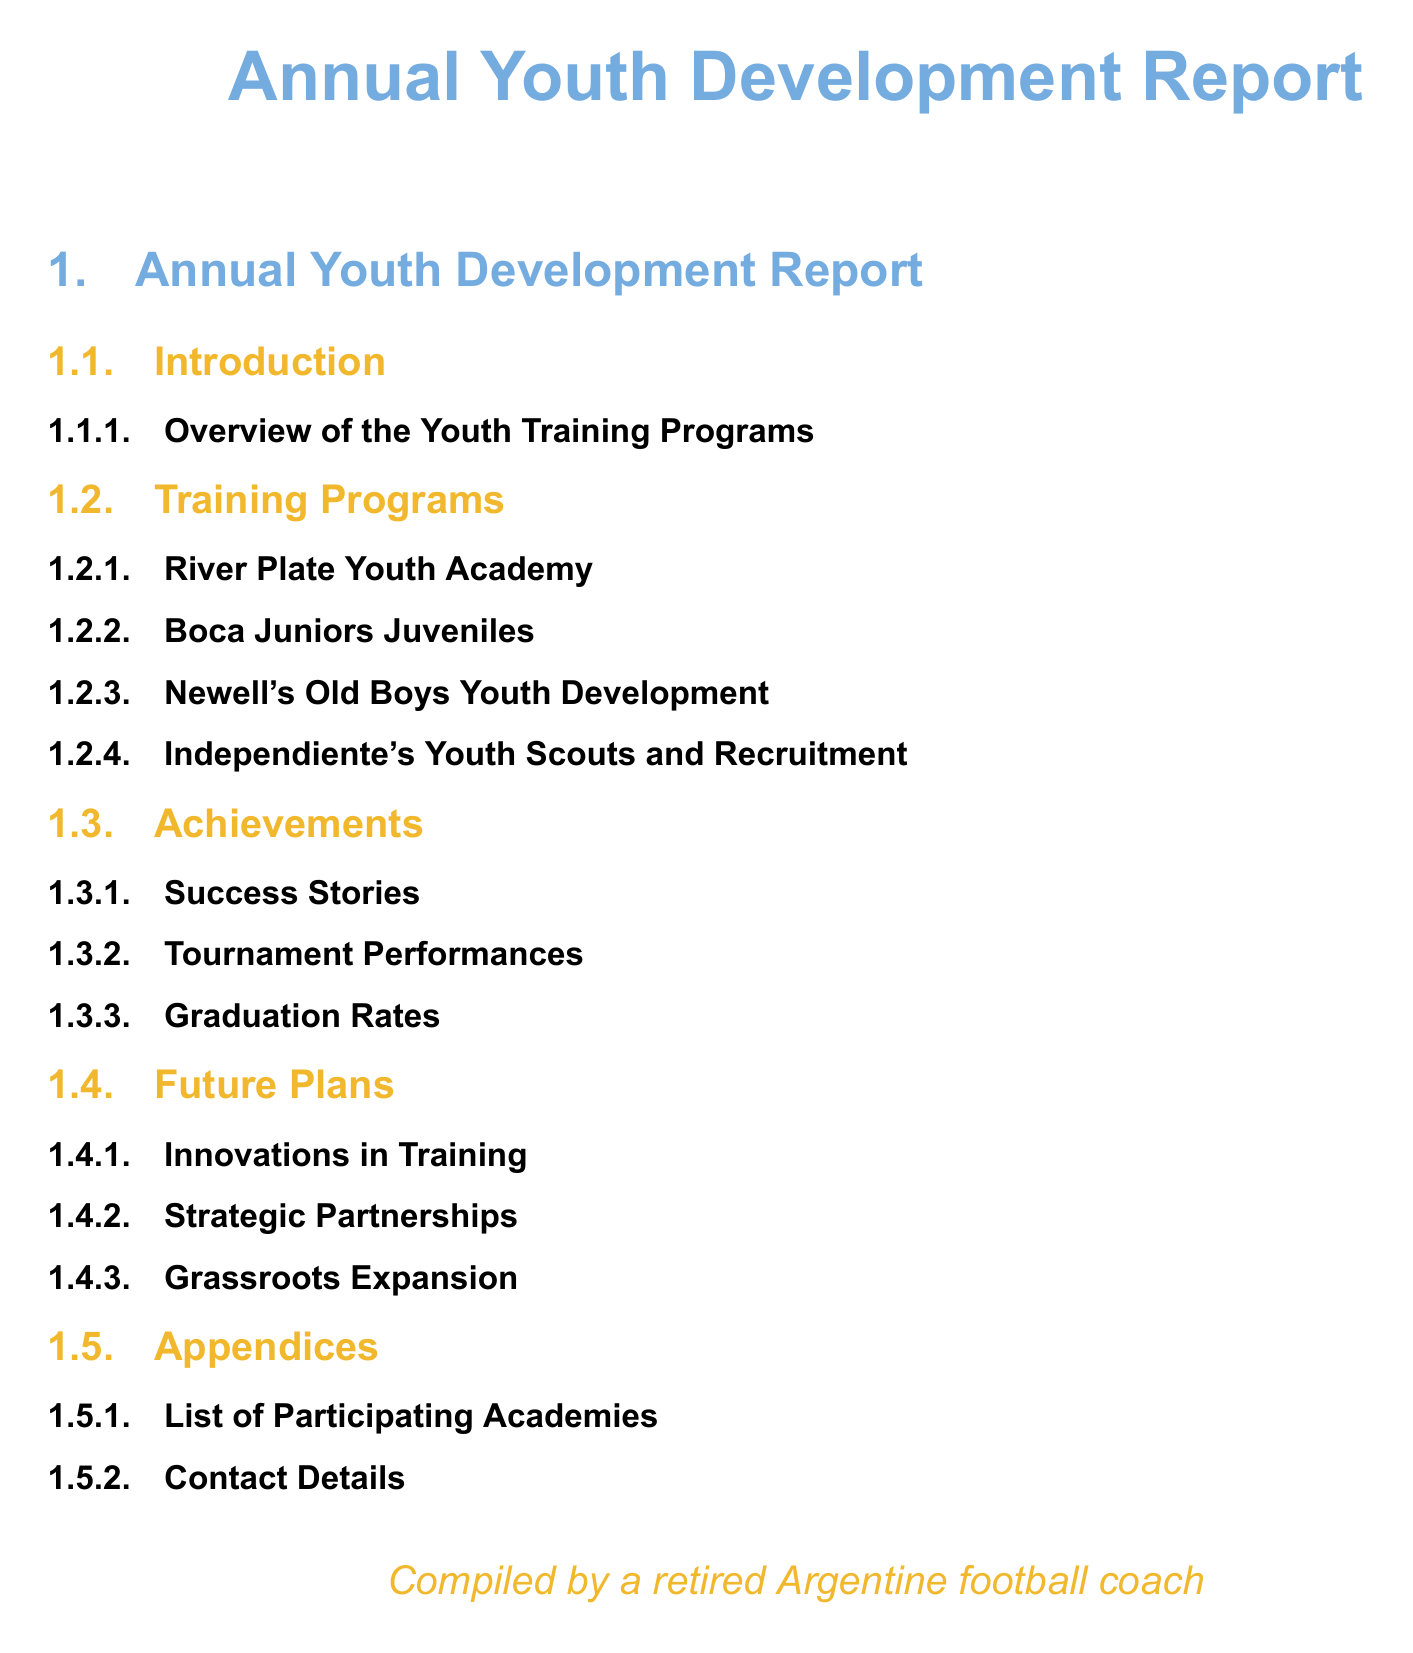what is the title of the report? The title of the report is prominently displayed at the top of the document.
Answer: Annual Youth Development Report how many youth training programs are listed? The number of youth training programs can be determined by counting the subsubsections under Training Programs.
Answer: 4 name one of the youth academies mentioned. This can be found in the Training Programs section, which lists participating academies.
Answer: River Plate Youth Academy what color is used for the section titles? The color of the section titles is specified within the document formatting settings.
Answer: Argentine blue what is one focus area for future plans? This can be identified in the Future Plans section where various strategies are outlined.
Answer: Innovations in Training who compiled the report? The document attributes the compilation to a specific individual noted at the bottom.
Answer: a retired Argentine football coach what is one of the achievements highlighted in the report? Achievements are outlined in a designated section, providing several examples.
Answer: Success Stories how many subsections are under the Achievements section? The number of subsections can be found by counting the items listed within the Achievements section.
Answer: 3 